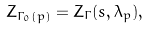<formula> <loc_0><loc_0><loc_500><loc_500>Z _ { \Gamma _ { 0 } ( p ) } = Z _ { \Gamma } ( s , \lambda _ { p } ) ,</formula> 